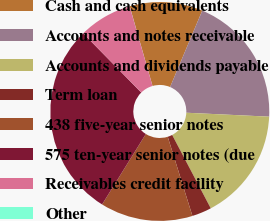<chart> <loc_0><loc_0><loc_500><loc_500><pie_chart><fcel>Cash and cash equivalents<fcel>Accounts and notes receivable<fcel>Accounts and dividends payable<fcel>Term loan<fcel>438 five-year senior notes<fcel>575 ten-year senior notes (due<fcel>Receivables credit facility<fcel>Other<nl><fcel>10.78%<fcel>19.42%<fcel>16.54%<fcel>2.89%<fcel>13.66%<fcel>28.81%<fcel>7.9%<fcel>0.01%<nl></chart> 